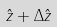<formula> <loc_0><loc_0><loc_500><loc_500>\hat { z } + \Delta \hat { z }</formula> 